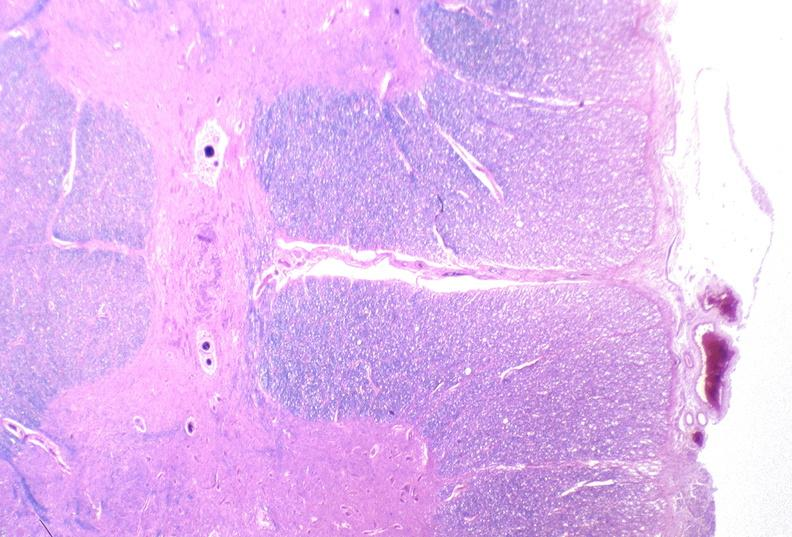what does this image show?
Answer the question using a single word or phrase. Spinal cord injury due to vertebral column trauma 